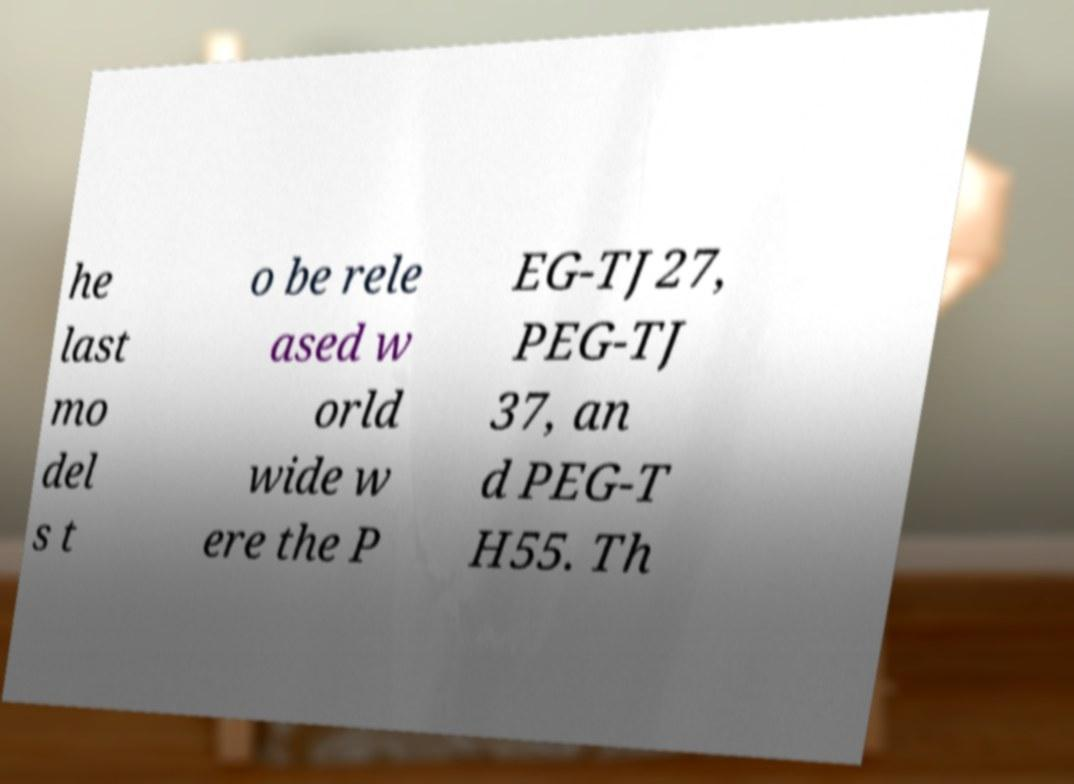There's text embedded in this image that I need extracted. Can you transcribe it verbatim? he last mo del s t o be rele ased w orld wide w ere the P EG-TJ27, PEG-TJ 37, an d PEG-T H55. Th 